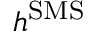Convert formula to latex. <formula><loc_0><loc_0><loc_500><loc_500>h ^ { S M S }</formula> 